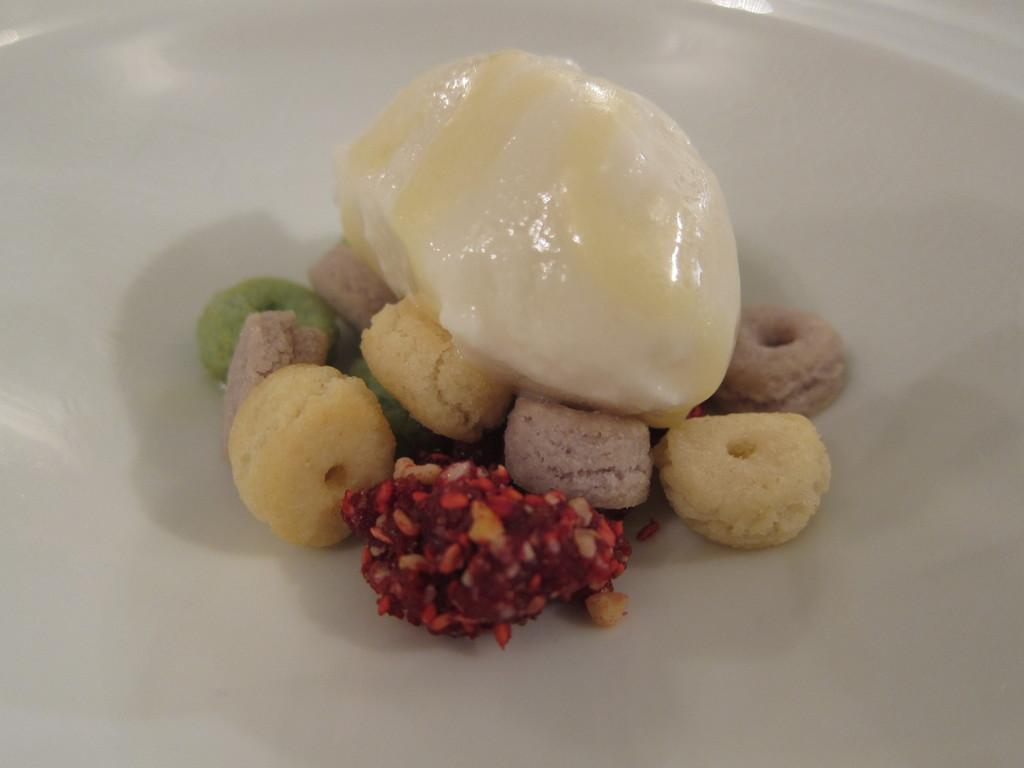What is the main object on the serving plate in the image? The serving plate contains dessert. Can you describe the dessert on the serving plate? Unfortunately, the specific type of dessert cannot be determined from the provided facts. What day of the week is it according to the calendar in the image? There is no calendar present in the image, so it is not possible to determine the day of the week. 